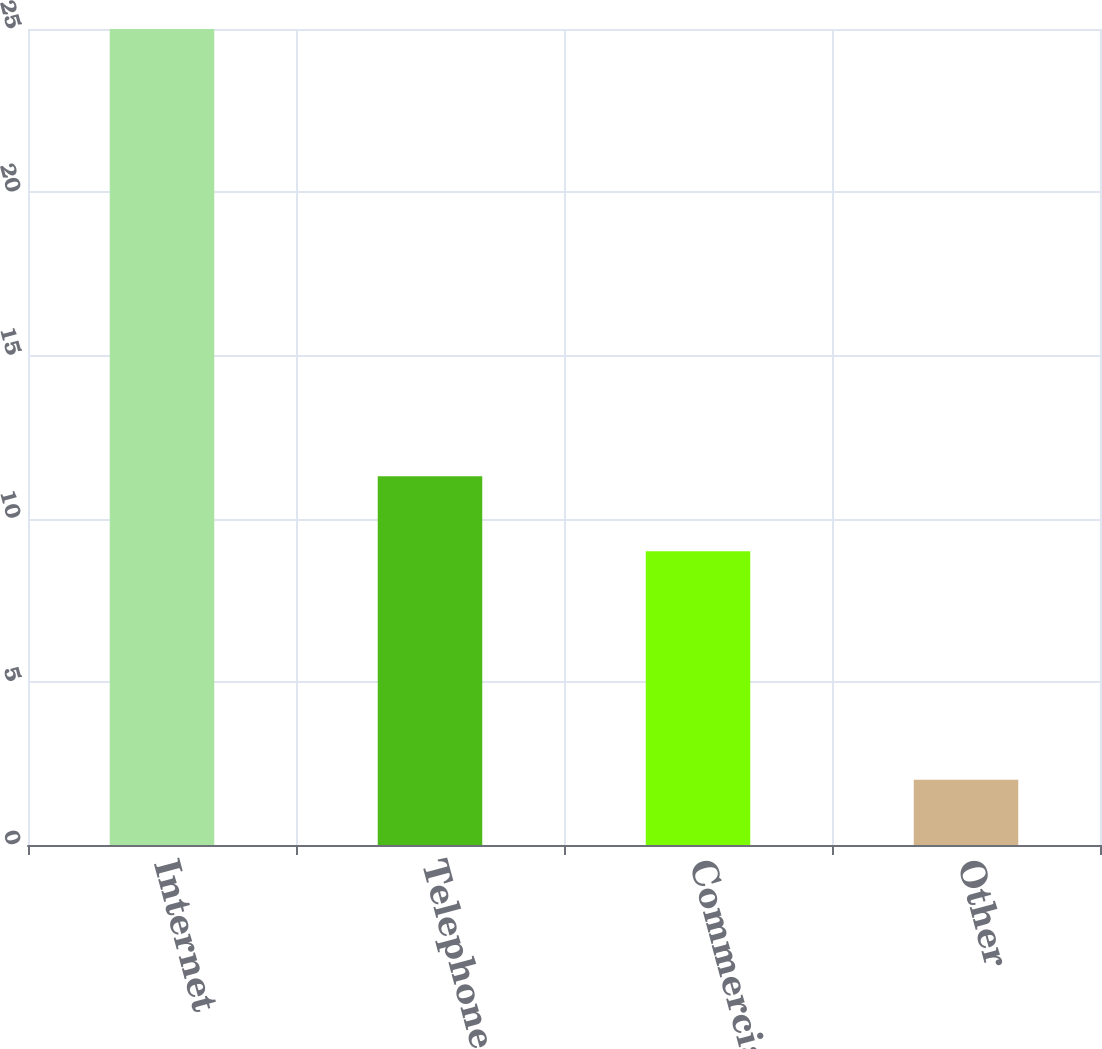Convert chart to OTSL. <chart><loc_0><loc_0><loc_500><loc_500><bar_chart><fcel>Internet<fcel>Telephone<fcel>Commercial<fcel>Other<nl><fcel>25<fcel>11.3<fcel>9<fcel>2<nl></chart> 